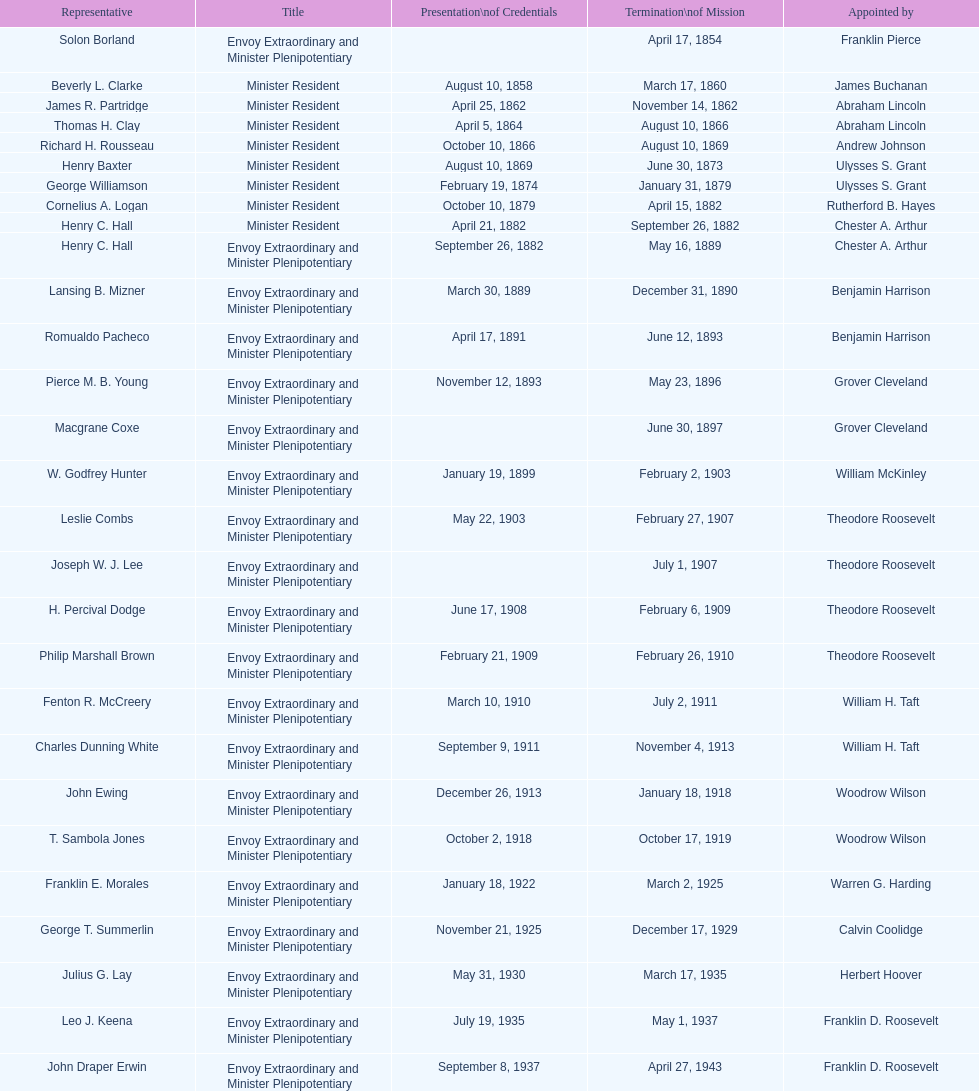Which envoy was the first appointed by woodrow wilson? John Ewing. 